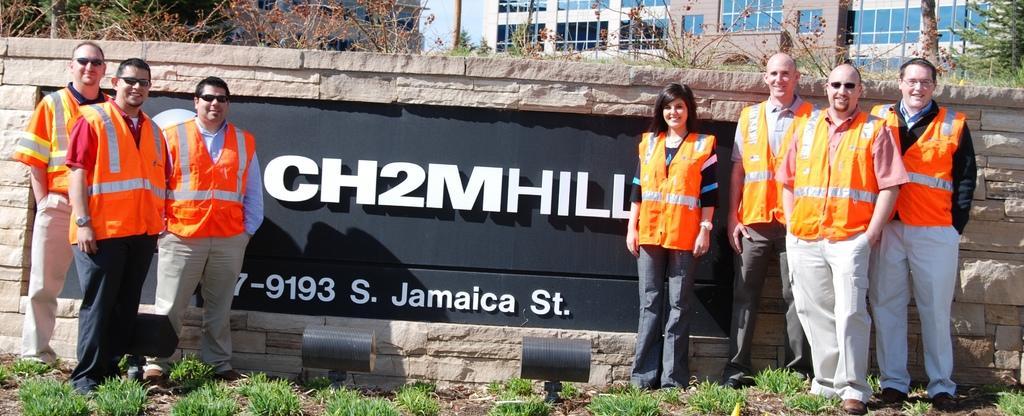In one or two sentences, can you explain what this image depicts? In this image we can see some people standing beside the wall. We can also see some grass, a building, plants, pole and the sky. 